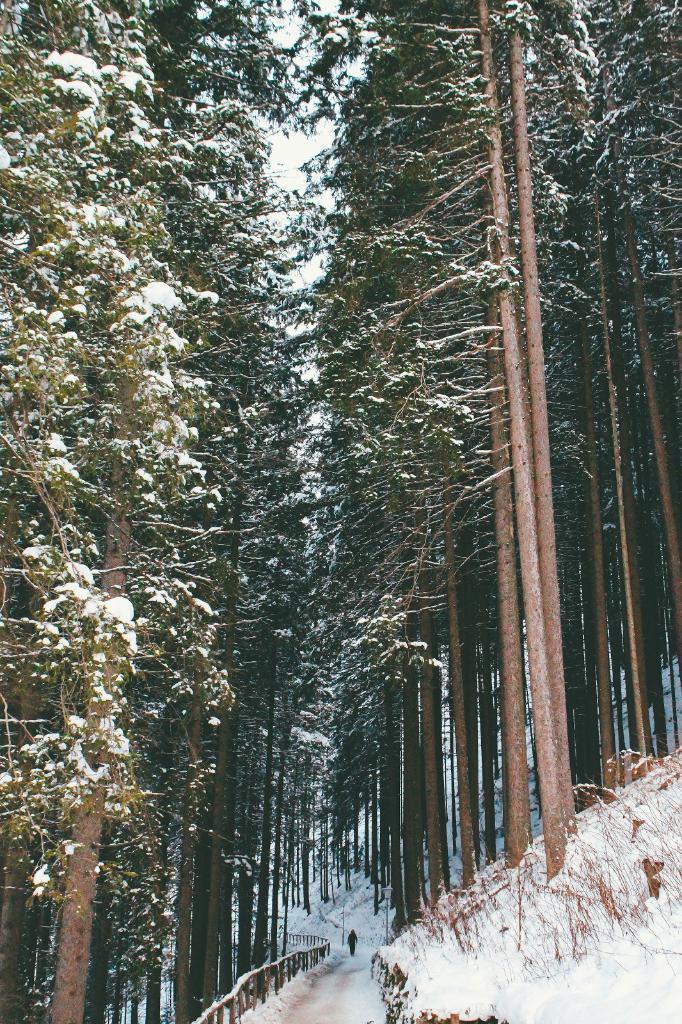Could you give a brief overview of what you see in this image? At the bottom of the picture, we see a man walking on the bridge which is covered with ice. There are many trees and these trees are covered with ice. 